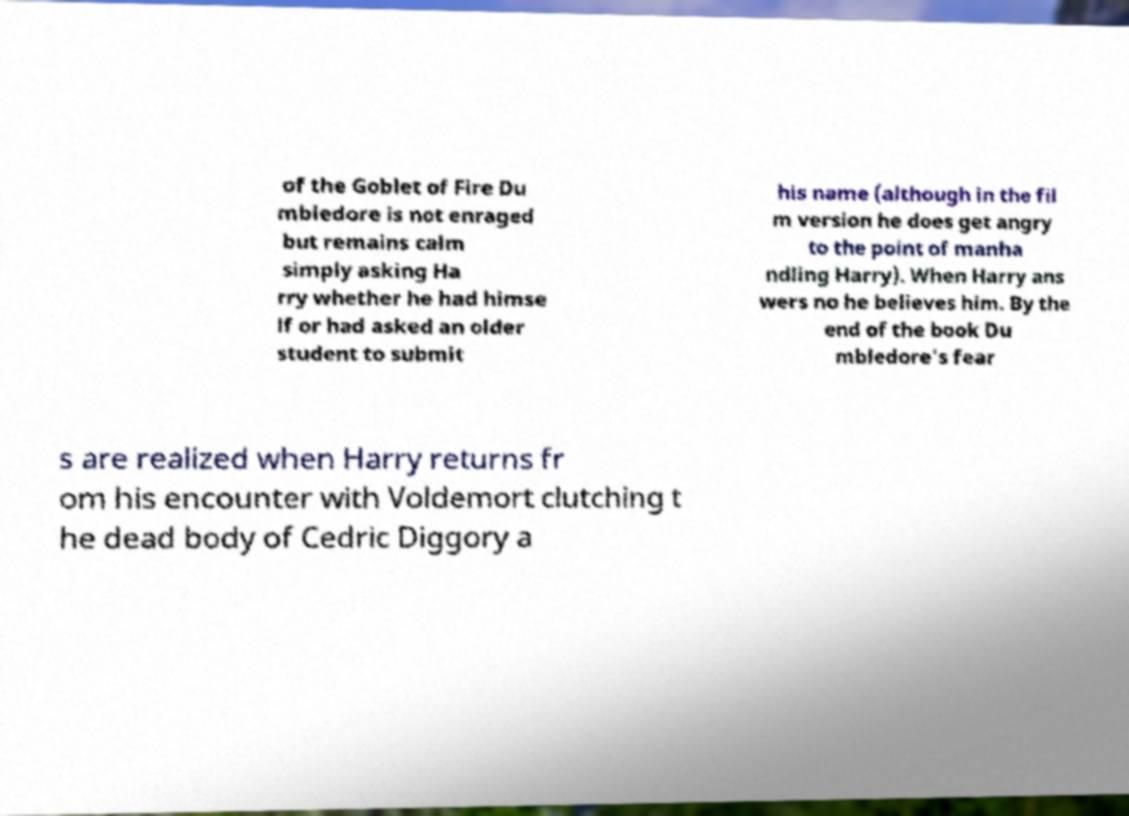There's text embedded in this image that I need extracted. Can you transcribe it verbatim? of the Goblet of Fire Du mbledore is not enraged but remains calm simply asking Ha rry whether he had himse lf or had asked an older student to submit his name (although in the fil m version he does get angry to the point of manha ndling Harry). When Harry ans wers no he believes him. By the end of the book Du mbledore's fear s are realized when Harry returns fr om his encounter with Voldemort clutching t he dead body of Cedric Diggory a 